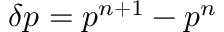Convert formula to latex. <formula><loc_0><loc_0><loc_500><loc_500>\delta p = p ^ { n + 1 } - p ^ { n }</formula> 